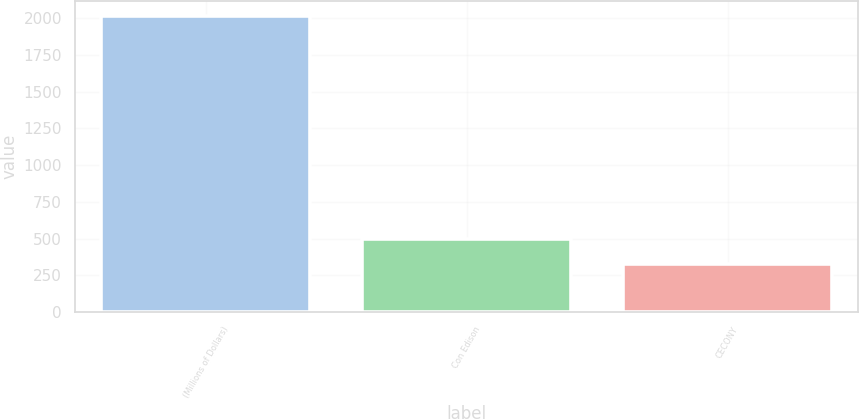Convert chart. <chart><loc_0><loc_0><loc_500><loc_500><bar_chart><fcel>(Millions of Dollars)<fcel>Con Edison<fcel>CECONY<nl><fcel>2013<fcel>497.4<fcel>329<nl></chart> 